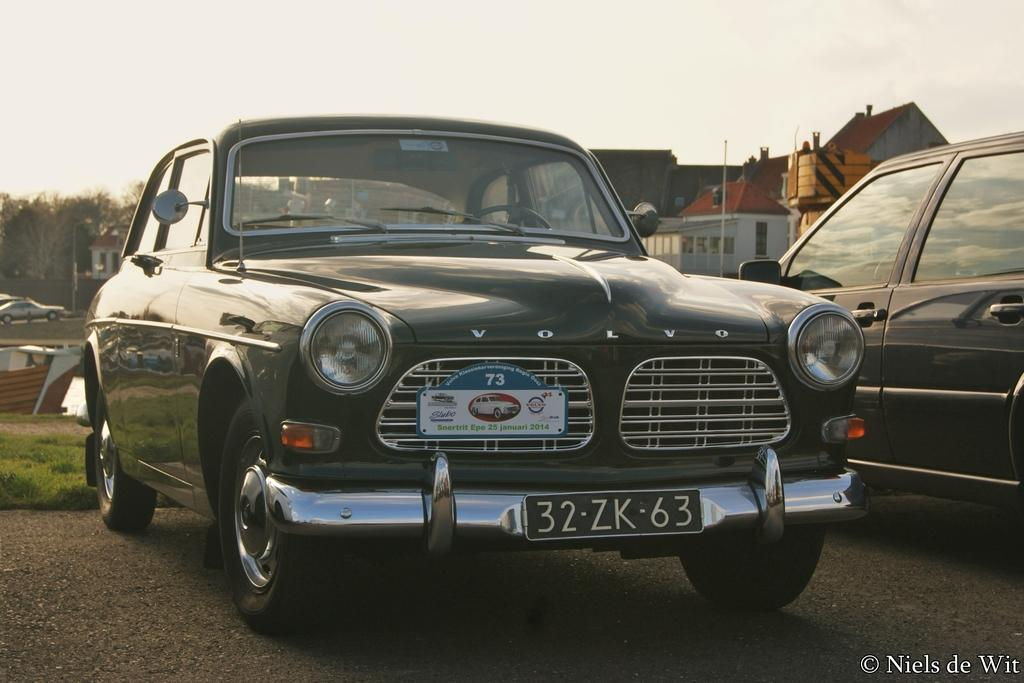How many cars can be seen on the road in the image? There are two cars on the road in the image. What type of vegetation is present on the ground in the background? There is grass on the ground in the background. What else can be seen on the road in the background? There are vehicles on the road in the background. What structures are visible in the background? There are poles, trees, houses, a fence, windows, and roofs visible in the background. What part of the natural environment is visible in the background? The sky is visible in the background. What is the voice of the corn in the image? There is no corn present in the image, so it is not possible to determine its voice. What is the tendency of the cars to move in the image? The question about the "tendency" of the cars is unclear and cannot be answered definitively based on the provided facts. However, the cars are on the road, which suggests they are in motion or have the potential to move. 